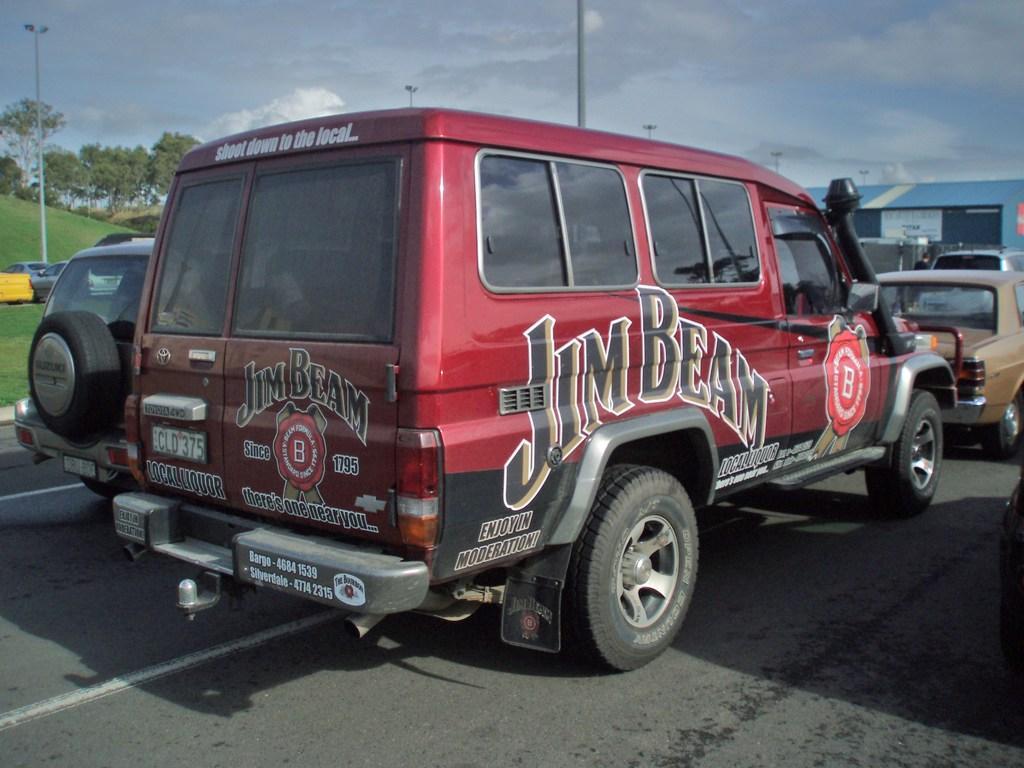How would you summarize this image in a sentence or two? In this image we can see the vehicles on the road. And we can see a shed and the poles. There are trees, grass and sky in the background. 